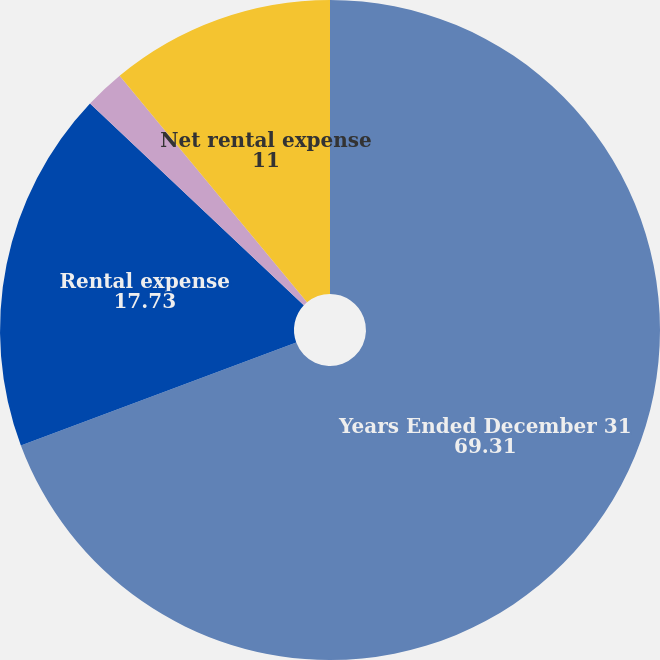Convert chart to OTSL. <chart><loc_0><loc_0><loc_500><loc_500><pie_chart><fcel>Years Ended December 31<fcel>Rental expense<fcel>Sub lease rental income<fcel>Net rental expense<nl><fcel>69.31%<fcel>17.73%<fcel>1.96%<fcel>11.0%<nl></chart> 